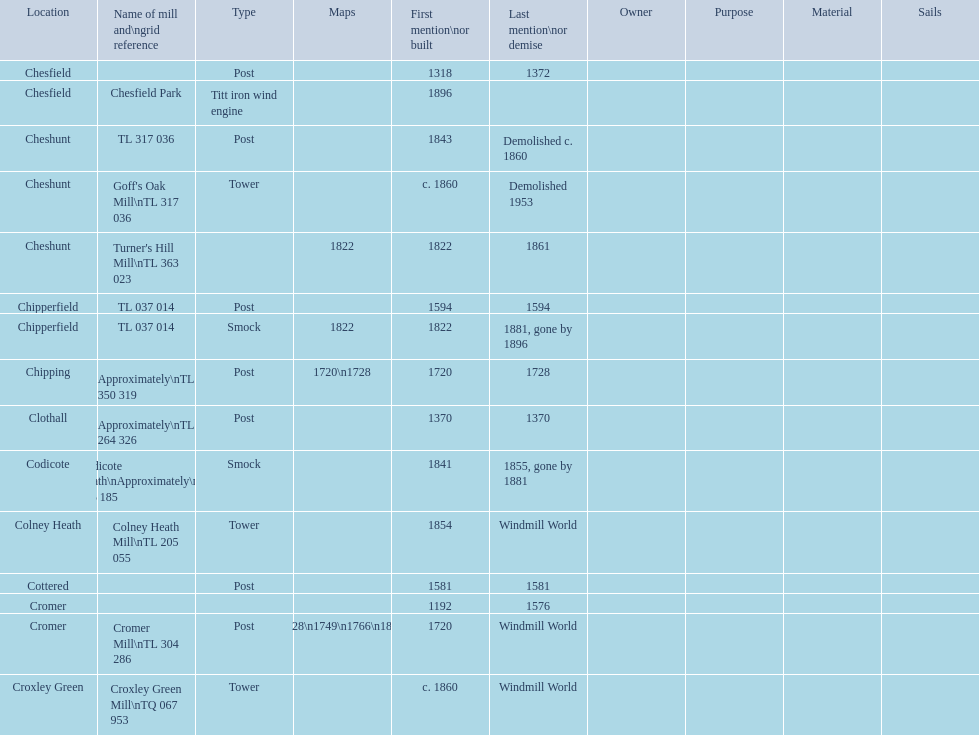Did cromer, chipperfield or cheshunt have the most windmills? Cheshunt. 